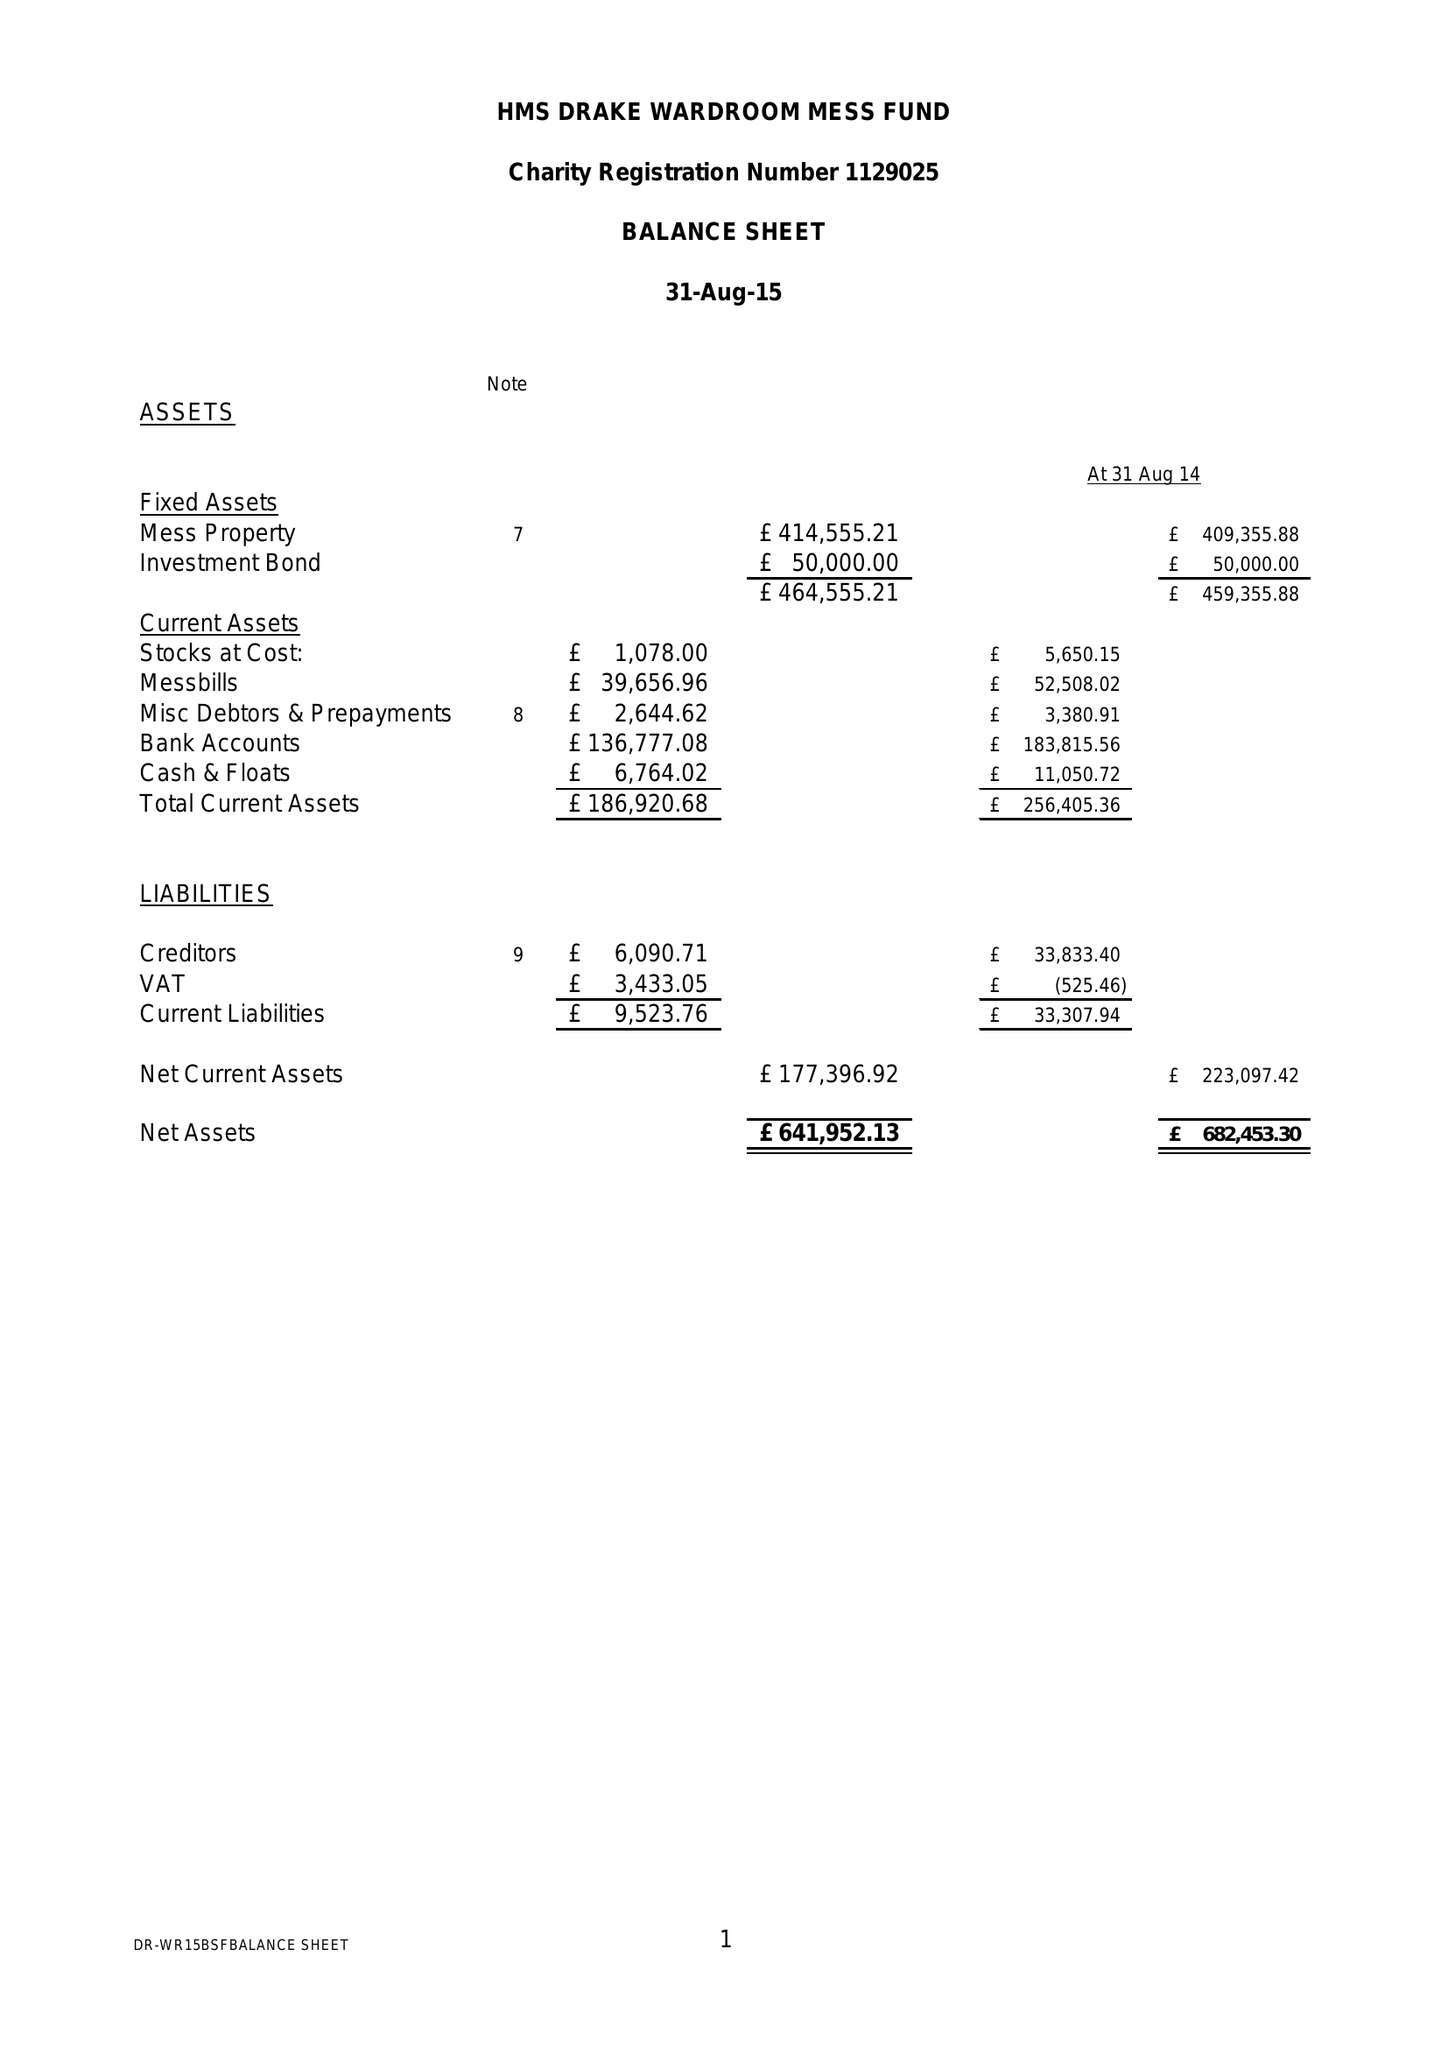What is the value for the income_annually_in_british_pounds?
Answer the question using a single word or phrase. 179463.00 